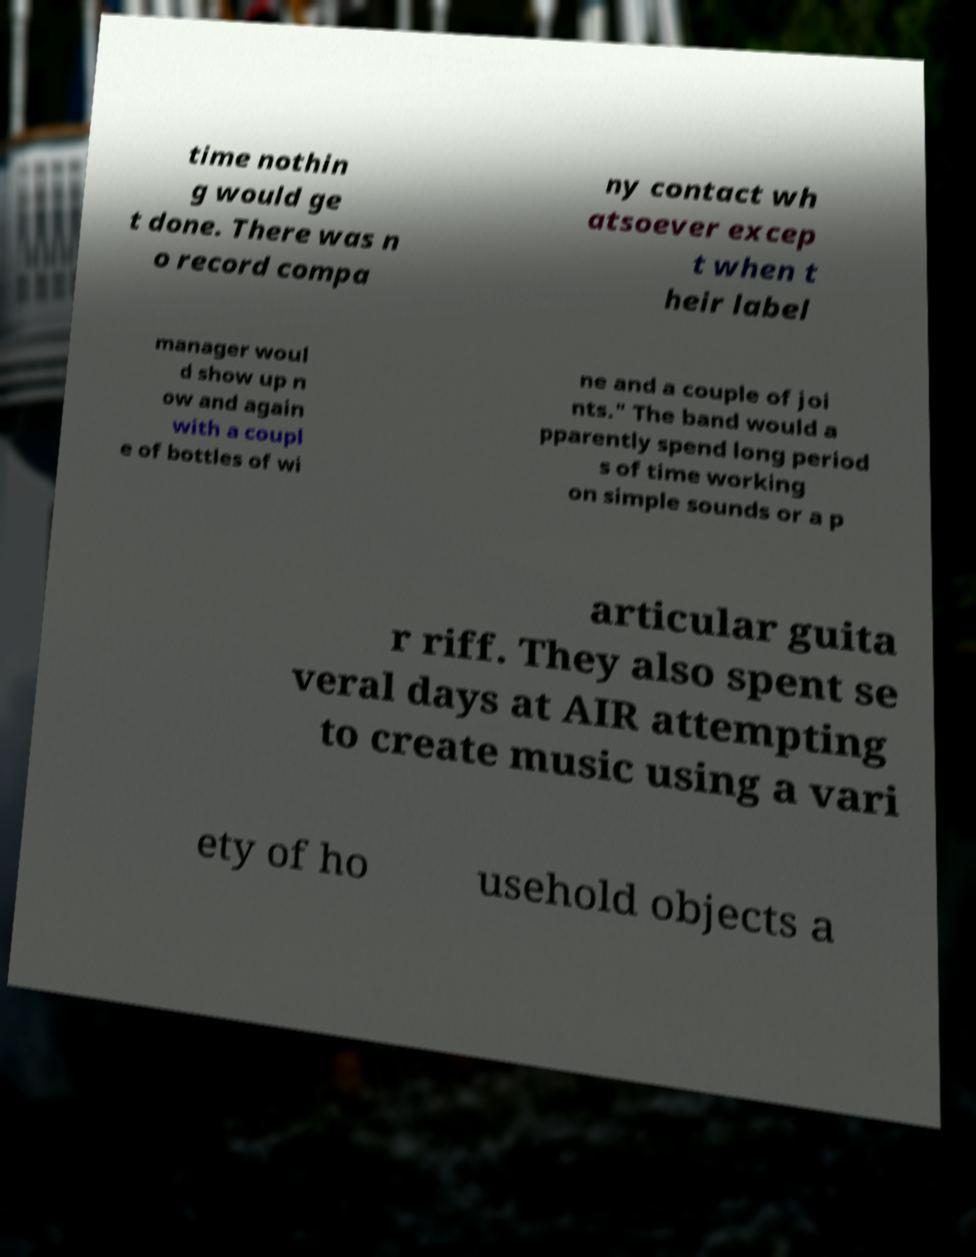I need the written content from this picture converted into text. Can you do that? time nothin g would ge t done. There was n o record compa ny contact wh atsoever excep t when t heir label manager woul d show up n ow and again with a coupl e of bottles of wi ne and a couple of joi nts." The band would a pparently spend long period s of time working on simple sounds or a p articular guita r riff. They also spent se veral days at AIR attempting to create music using a vari ety of ho usehold objects a 